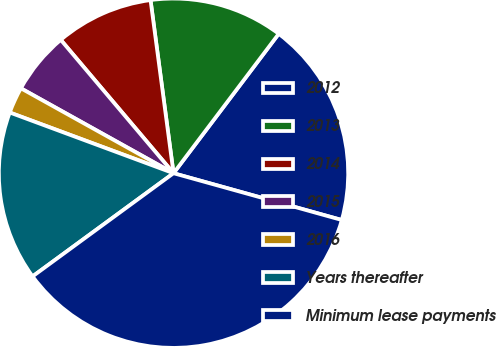Convert chart. <chart><loc_0><loc_0><loc_500><loc_500><pie_chart><fcel>2012<fcel>2013<fcel>2014<fcel>2015<fcel>2016<fcel>Years thereafter<fcel>Minimum lease payments<nl><fcel>19.03%<fcel>12.39%<fcel>9.07%<fcel>5.75%<fcel>2.43%<fcel>15.71%<fcel>35.63%<nl></chart> 